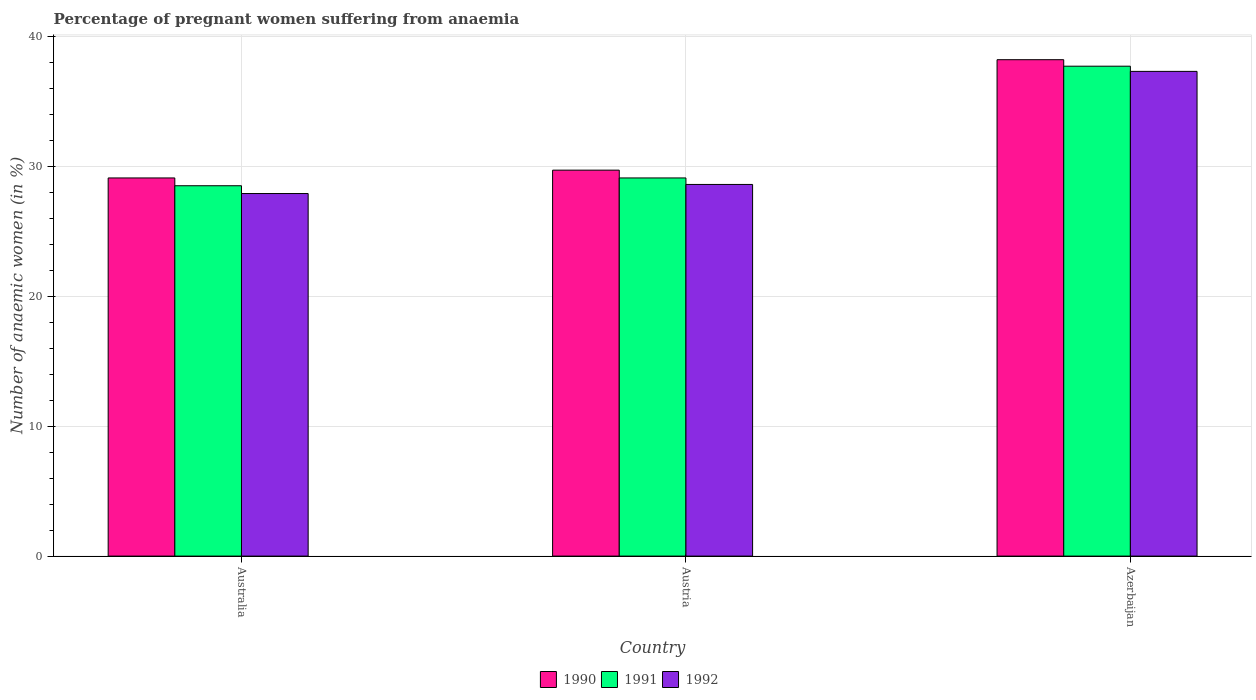How many groups of bars are there?
Give a very brief answer. 3. Are the number of bars per tick equal to the number of legend labels?
Keep it short and to the point. Yes. Are the number of bars on each tick of the X-axis equal?
Your answer should be compact. Yes. How many bars are there on the 2nd tick from the left?
Your answer should be compact. 3. How many bars are there on the 2nd tick from the right?
Keep it short and to the point. 3. What is the label of the 3rd group of bars from the left?
Provide a succinct answer. Azerbaijan. What is the number of anaemic women in 1992 in Australia?
Keep it short and to the point. 27.9. Across all countries, what is the maximum number of anaemic women in 1990?
Your answer should be very brief. 38.2. Across all countries, what is the minimum number of anaemic women in 1990?
Offer a terse response. 29.1. In which country was the number of anaemic women in 1991 maximum?
Ensure brevity in your answer.  Azerbaijan. In which country was the number of anaemic women in 1992 minimum?
Your response must be concise. Australia. What is the total number of anaemic women in 1992 in the graph?
Your answer should be compact. 93.8. What is the difference between the number of anaemic women in 1990 in Australia and that in Austria?
Your answer should be compact. -0.6. What is the difference between the number of anaemic women in 1990 in Austria and the number of anaemic women in 1991 in Azerbaijan?
Provide a succinct answer. -8. What is the average number of anaemic women in 1990 per country?
Your answer should be compact. 32.33. What is the difference between the number of anaemic women of/in 1991 and number of anaemic women of/in 1992 in Austria?
Make the answer very short. 0.5. What is the ratio of the number of anaemic women in 1990 in Australia to that in Azerbaijan?
Provide a succinct answer. 0.76. What is the difference between the highest and the second highest number of anaemic women in 1991?
Provide a short and direct response. 0.6. What is the difference between the highest and the lowest number of anaemic women in 1991?
Keep it short and to the point. 9.2. Is the sum of the number of anaemic women in 1992 in Australia and Austria greater than the maximum number of anaemic women in 1990 across all countries?
Your answer should be compact. Yes. How many countries are there in the graph?
Make the answer very short. 3. Does the graph contain any zero values?
Give a very brief answer. No. What is the title of the graph?
Provide a short and direct response. Percentage of pregnant women suffering from anaemia. Does "2003" appear as one of the legend labels in the graph?
Offer a terse response. No. What is the label or title of the X-axis?
Offer a very short reply. Country. What is the label or title of the Y-axis?
Keep it short and to the point. Number of anaemic women (in %). What is the Number of anaemic women (in %) of 1990 in Australia?
Ensure brevity in your answer.  29.1. What is the Number of anaemic women (in %) in 1992 in Australia?
Your answer should be compact. 27.9. What is the Number of anaemic women (in %) of 1990 in Austria?
Offer a terse response. 29.7. What is the Number of anaemic women (in %) of 1991 in Austria?
Ensure brevity in your answer.  29.1. What is the Number of anaemic women (in %) in 1992 in Austria?
Offer a terse response. 28.6. What is the Number of anaemic women (in %) in 1990 in Azerbaijan?
Provide a succinct answer. 38.2. What is the Number of anaemic women (in %) of 1991 in Azerbaijan?
Provide a succinct answer. 37.7. What is the Number of anaemic women (in %) of 1992 in Azerbaijan?
Offer a very short reply. 37.3. Across all countries, what is the maximum Number of anaemic women (in %) in 1990?
Make the answer very short. 38.2. Across all countries, what is the maximum Number of anaemic women (in %) in 1991?
Your response must be concise. 37.7. Across all countries, what is the maximum Number of anaemic women (in %) of 1992?
Keep it short and to the point. 37.3. Across all countries, what is the minimum Number of anaemic women (in %) of 1990?
Offer a terse response. 29.1. Across all countries, what is the minimum Number of anaemic women (in %) of 1992?
Make the answer very short. 27.9. What is the total Number of anaemic women (in %) of 1990 in the graph?
Offer a very short reply. 97. What is the total Number of anaemic women (in %) of 1991 in the graph?
Make the answer very short. 95.3. What is the total Number of anaemic women (in %) of 1992 in the graph?
Provide a short and direct response. 93.8. What is the difference between the Number of anaemic women (in %) of 1990 in Australia and that in Austria?
Your response must be concise. -0.6. What is the difference between the Number of anaemic women (in %) in 1991 in Australia and that in Azerbaijan?
Offer a terse response. -9.2. What is the difference between the Number of anaemic women (in %) in 1992 in Australia and that in Azerbaijan?
Your response must be concise. -9.4. What is the difference between the Number of anaemic women (in %) of 1991 in Austria and that in Azerbaijan?
Ensure brevity in your answer.  -8.6. What is the difference between the Number of anaemic women (in %) in 1992 in Austria and that in Azerbaijan?
Your response must be concise. -8.7. What is the difference between the Number of anaemic women (in %) of 1990 in Australia and the Number of anaemic women (in %) of 1991 in Austria?
Provide a succinct answer. 0. What is the difference between the Number of anaemic women (in %) of 1990 in Australia and the Number of anaemic women (in %) of 1991 in Azerbaijan?
Your answer should be very brief. -8.6. What is the difference between the Number of anaemic women (in %) of 1990 in Austria and the Number of anaemic women (in %) of 1992 in Azerbaijan?
Give a very brief answer. -7.6. What is the difference between the Number of anaemic women (in %) of 1991 in Austria and the Number of anaemic women (in %) of 1992 in Azerbaijan?
Offer a terse response. -8.2. What is the average Number of anaemic women (in %) in 1990 per country?
Provide a short and direct response. 32.33. What is the average Number of anaemic women (in %) in 1991 per country?
Provide a short and direct response. 31.77. What is the average Number of anaemic women (in %) of 1992 per country?
Ensure brevity in your answer.  31.27. What is the difference between the Number of anaemic women (in %) in 1990 and Number of anaemic women (in %) in 1992 in Australia?
Ensure brevity in your answer.  1.2. What is the difference between the Number of anaemic women (in %) of 1991 and Number of anaemic women (in %) of 1992 in Australia?
Your answer should be compact. 0.6. What is the difference between the Number of anaemic women (in %) of 1990 and Number of anaemic women (in %) of 1992 in Austria?
Your response must be concise. 1.1. What is the ratio of the Number of anaemic women (in %) in 1990 in Australia to that in Austria?
Keep it short and to the point. 0.98. What is the ratio of the Number of anaemic women (in %) in 1991 in Australia to that in Austria?
Ensure brevity in your answer.  0.98. What is the ratio of the Number of anaemic women (in %) in 1992 in Australia to that in Austria?
Make the answer very short. 0.98. What is the ratio of the Number of anaemic women (in %) of 1990 in Australia to that in Azerbaijan?
Offer a very short reply. 0.76. What is the ratio of the Number of anaemic women (in %) of 1991 in Australia to that in Azerbaijan?
Ensure brevity in your answer.  0.76. What is the ratio of the Number of anaemic women (in %) in 1992 in Australia to that in Azerbaijan?
Provide a short and direct response. 0.75. What is the ratio of the Number of anaemic women (in %) of 1990 in Austria to that in Azerbaijan?
Provide a short and direct response. 0.78. What is the ratio of the Number of anaemic women (in %) of 1991 in Austria to that in Azerbaijan?
Offer a terse response. 0.77. What is the ratio of the Number of anaemic women (in %) in 1992 in Austria to that in Azerbaijan?
Make the answer very short. 0.77. What is the difference between the highest and the second highest Number of anaemic women (in %) of 1990?
Your response must be concise. 8.5. What is the difference between the highest and the second highest Number of anaemic women (in %) of 1991?
Give a very brief answer. 8.6. 